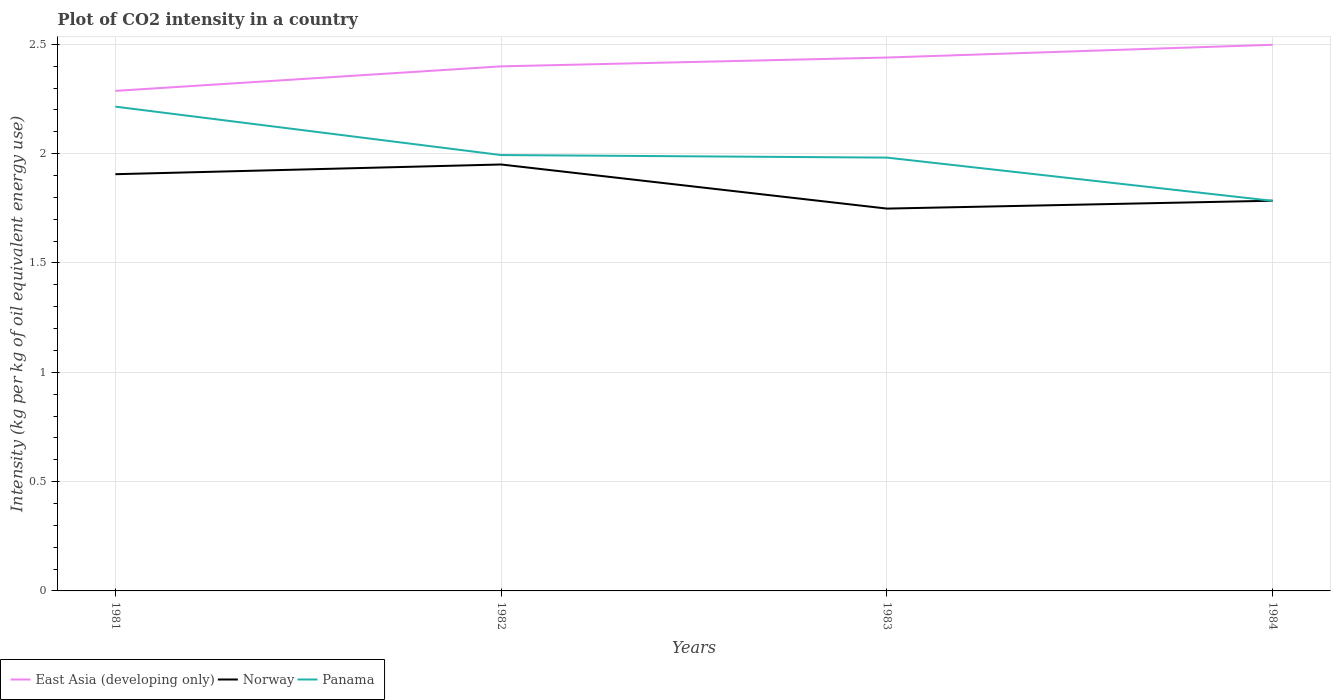Is the number of lines equal to the number of legend labels?
Your response must be concise. Yes. Across all years, what is the maximum CO2 intensity in in Panama?
Provide a succinct answer. 1.78. In which year was the CO2 intensity in in Panama maximum?
Offer a terse response. 1984. What is the total CO2 intensity in in East Asia (developing only) in the graph?
Ensure brevity in your answer.  -0.06. What is the difference between the highest and the second highest CO2 intensity in in Norway?
Make the answer very short. 0.2. Is the CO2 intensity in in Panama strictly greater than the CO2 intensity in in East Asia (developing only) over the years?
Provide a short and direct response. Yes. How many years are there in the graph?
Keep it short and to the point. 4. Does the graph contain any zero values?
Your answer should be compact. No. Does the graph contain grids?
Provide a short and direct response. Yes. How are the legend labels stacked?
Your answer should be very brief. Horizontal. What is the title of the graph?
Offer a terse response. Plot of CO2 intensity in a country. What is the label or title of the X-axis?
Offer a terse response. Years. What is the label or title of the Y-axis?
Your answer should be compact. Intensity (kg per kg of oil equivalent energy use). What is the Intensity (kg per kg of oil equivalent energy use) of East Asia (developing only) in 1981?
Provide a short and direct response. 2.29. What is the Intensity (kg per kg of oil equivalent energy use) in Norway in 1981?
Make the answer very short. 1.91. What is the Intensity (kg per kg of oil equivalent energy use) of Panama in 1981?
Your answer should be very brief. 2.22. What is the Intensity (kg per kg of oil equivalent energy use) of East Asia (developing only) in 1982?
Keep it short and to the point. 2.4. What is the Intensity (kg per kg of oil equivalent energy use) in Norway in 1982?
Offer a very short reply. 1.95. What is the Intensity (kg per kg of oil equivalent energy use) in Panama in 1982?
Offer a very short reply. 1.99. What is the Intensity (kg per kg of oil equivalent energy use) of East Asia (developing only) in 1983?
Give a very brief answer. 2.44. What is the Intensity (kg per kg of oil equivalent energy use) in Norway in 1983?
Provide a short and direct response. 1.75. What is the Intensity (kg per kg of oil equivalent energy use) in Panama in 1983?
Keep it short and to the point. 1.98. What is the Intensity (kg per kg of oil equivalent energy use) in East Asia (developing only) in 1984?
Provide a short and direct response. 2.5. What is the Intensity (kg per kg of oil equivalent energy use) in Norway in 1984?
Your answer should be compact. 1.78. What is the Intensity (kg per kg of oil equivalent energy use) of Panama in 1984?
Make the answer very short. 1.78. Across all years, what is the maximum Intensity (kg per kg of oil equivalent energy use) in East Asia (developing only)?
Ensure brevity in your answer.  2.5. Across all years, what is the maximum Intensity (kg per kg of oil equivalent energy use) in Norway?
Provide a succinct answer. 1.95. Across all years, what is the maximum Intensity (kg per kg of oil equivalent energy use) in Panama?
Keep it short and to the point. 2.22. Across all years, what is the minimum Intensity (kg per kg of oil equivalent energy use) of East Asia (developing only)?
Keep it short and to the point. 2.29. Across all years, what is the minimum Intensity (kg per kg of oil equivalent energy use) in Norway?
Make the answer very short. 1.75. Across all years, what is the minimum Intensity (kg per kg of oil equivalent energy use) of Panama?
Your answer should be compact. 1.78. What is the total Intensity (kg per kg of oil equivalent energy use) in East Asia (developing only) in the graph?
Your response must be concise. 9.62. What is the total Intensity (kg per kg of oil equivalent energy use) in Norway in the graph?
Make the answer very short. 7.39. What is the total Intensity (kg per kg of oil equivalent energy use) in Panama in the graph?
Keep it short and to the point. 7.97. What is the difference between the Intensity (kg per kg of oil equivalent energy use) in East Asia (developing only) in 1981 and that in 1982?
Your answer should be compact. -0.11. What is the difference between the Intensity (kg per kg of oil equivalent energy use) in Norway in 1981 and that in 1982?
Give a very brief answer. -0.04. What is the difference between the Intensity (kg per kg of oil equivalent energy use) of Panama in 1981 and that in 1982?
Make the answer very short. 0.22. What is the difference between the Intensity (kg per kg of oil equivalent energy use) of East Asia (developing only) in 1981 and that in 1983?
Provide a short and direct response. -0.15. What is the difference between the Intensity (kg per kg of oil equivalent energy use) of Norway in 1981 and that in 1983?
Offer a terse response. 0.16. What is the difference between the Intensity (kg per kg of oil equivalent energy use) in Panama in 1981 and that in 1983?
Provide a succinct answer. 0.23. What is the difference between the Intensity (kg per kg of oil equivalent energy use) of East Asia (developing only) in 1981 and that in 1984?
Your answer should be compact. -0.21. What is the difference between the Intensity (kg per kg of oil equivalent energy use) in Norway in 1981 and that in 1984?
Your response must be concise. 0.12. What is the difference between the Intensity (kg per kg of oil equivalent energy use) in Panama in 1981 and that in 1984?
Make the answer very short. 0.43. What is the difference between the Intensity (kg per kg of oil equivalent energy use) in East Asia (developing only) in 1982 and that in 1983?
Provide a succinct answer. -0.04. What is the difference between the Intensity (kg per kg of oil equivalent energy use) in Norway in 1982 and that in 1983?
Make the answer very short. 0.2. What is the difference between the Intensity (kg per kg of oil equivalent energy use) in Panama in 1982 and that in 1983?
Make the answer very short. 0.01. What is the difference between the Intensity (kg per kg of oil equivalent energy use) of East Asia (developing only) in 1982 and that in 1984?
Your answer should be very brief. -0.1. What is the difference between the Intensity (kg per kg of oil equivalent energy use) of Norway in 1982 and that in 1984?
Make the answer very short. 0.17. What is the difference between the Intensity (kg per kg of oil equivalent energy use) of Panama in 1982 and that in 1984?
Offer a very short reply. 0.21. What is the difference between the Intensity (kg per kg of oil equivalent energy use) in East Asia (developing only) in 1983 and that in 1984?
Make the answer very short. -0.06. What is the difference between the Intensity (kg per kg of oil equivalent energy use) in Norway in 1983 and that in 1984?
Offer a terse response. -0.04. What is the difference between the Intensity (kg per kg of oil equivalent energy use) in Panama in 1983 and that in 1984?
Provide a succinct answer. 0.2. What is the difference between the Intensity (kg per kg of oil equivalent energy use) in East Asia (developing only) in 1981 and the Intensity (kg per kg of oil equivalent energy use) in Norway in 1982?
Ensure brevity in your answer.  0.34. What is the difference between the Intensity (kg per kg of oil equivalent energy use) in East Asia (developing only) in 1981 and the Intensity (kg per kg of oil equivalent energy use) in Panama in 1982?
Provide a short and direct response. 0.29. What is the difference between the Intensity (kg per kg of oil equivalent energy use) in Norway in 1981 and the Intensity (kg per kg of oil equivalent energy use) in Panama in 1982?
Give a very brief answer. -0.09. What is the difference between the Intensity (kg per kg of oil equivalent energy use) in East Asia (developing only) in 1981 and the Intensity (kg per kg of oil equivalent energy use) in Norway in 1983?
Your answer should be compact. 0.54. What is the difference between the Intensity (kg per kg of oil equivalent energy use) in East Asia (developing only) in 1981 and the Intensity (kg per kg of oil equivalent energy use) in Panama in 1983?
Offer a terse response. 0.31. What is the difference between the Intensity (kg per kg of oil equivalent energy use) of Norway in 1981 and the Intensity (kg per kg of oil equivalent energy use) of Panama in 1983?
Give a very brief answer. -0.08. What is the difference between the Intensity (kg per kg of oil equivalent energy use) of East Asia (developing only) in 1981 and the Intensity (kg per kg of oil equivalent energy use) of Norway in 1984?
Provide a succinct answer. 0.5. What is the difference between the Intensity (kg per kg of oil equivalent energy use) of East Asia (developing only) in 1981 and the Intensity (kg per kg of oil equivalent energy use) of Panama in 1984?
Offer a very short reply. 0.5. What is the difference between the Intensity (kg per kg of oil equivalent energy use) of Norway in 1981 and the Intensity (kg per kg of oil equivalent energy use) of Panama in 1984?
Offer a terse response. 0.12. What is the difference between the Intensity (kg per kg of oil equivalent energy use) of East Asia (developing only) in 1982 and the Intensity (kg per kg of oil equivalent energy use) of Norway in 1983?
Offer a very short reply. 0.65. What is the difference between the Intensity (kg per kg of oil equivalent energy use) of East Asia (developing only) in 1982 and the Intensity (kg per kg of oil equivalent energy use) of Panama in 1983?
Make the answer very short. 0.42. What is the difference between the Intensity (kg per kg of oil equivalent energy use) of Norway in 1982 and the Intensity (kg per kg of oil equivalent energy use) of Panama in 1983?
Your response must be concise. -0.03. What is the difference between the Intensity (kg per kg of oil equivalent energy use) of East Asia (developing only) in 1982 and the Intensity (kg per kg of oil equivalent energy use) of Norway in 1984?
Provide a succinct answer. 0.61. What is the difference between the Intensity (kg per kg of oil equivalent energy use) in East Asia (developing only) in 1982 and the Intensity (kg per kg of oil equivalent energy use) in Panama in 1984?
Provide a succinct answer. 0.62. What is the difference between the Intensity (kg per kg of oil equivalent energy use) of Norway in 1982 and the Intensity (kg per kg of oil equivalent energy use) of Panama in 1984?
Give a very brief answer. 0.17. What is the difference between the Intensity (kg per kg of oil equivalent energy use) in East Asia (developing only) in 1983 and the Intensity (kg per kg of oil equivalent energy use) in Norway in 1984?
Offer a very short reply. 0.65. What is the difference between the Intensity (kg per kg of oil equivalent energy use) of East Asia (developing only) in 1983 and the Intensity (kg per kg of oil equivalent energy use) of Panama in 1984?
Your response must be concise. 0.66. What is the difference between the Intensity (kg per kg of oil equivalent energy use) of Norway in 1983 and the Intensity (kg per kg of oil equivalent energy use) of Panama in 1984?
Your answer should be very brief. -0.04. What is the average Intensity (kg per kg of oil equivalent energy use) in East Asia (developing only) per year?
Offer a very short reply. 2.41. What is the average Intensity (kg per kg of oil equivalent energy use) of Norway per year?
Provide a short and direct response. 1.85. What is the average Intensity (kg per kg of oil equivalent energy use) in Panama per year?
Your answer should be very brief. 1.99. In the year 1981, what is the difference between the Intensity (kg per kg of oil equivalent energy use) in East Asia (developing only) and Intensity (kg per kg of oil equivalent energy use) in Norway?
Your answer should be very brief. 0.38. In the year 1981, what is the difference between the Intensity (kg per kg of oil equivalent energy use) in East Asia (developing only) and Intensity (kg per kg of oil equivalent energy use) in Panama?
Offer a terse response. 0.07. In the year 1981, what is the difference between the Intensity (kg per kg of oil equivalent energy use) in Norway and Intensity (kg per kg of oil equivalent energy use) in Panama?
Make the answer very short. -0.31. In the year 1982, what is the difference between the Intensity (kg per kg of oil equivalent energy use) of East Asia (developing only) and Intensity (kg per kg of oil equivalent energy use) of Norway?
Give a very brief answer. 0.45. In the year 1982, what is the difference between the Intensity (kg per kg of oil equivalent energy use) in East Asia (developing only) and Intensity (kg per kg of oil equivalent energy use) in Panama?
Your answer should be compact. 0.41. In the year 1982, what is the difference between the Intensity (kg per kg of oil equivalent energy use) of Norway and Intensity (kg per kg of oil equivalent energy use) of Panama?
Your answer should be very brief. -0.04. In the year 1983, what is the difference between the Intensity (kg per kg of oil equivalent energy use) in East Asia (developing only) and Intensity (kg per kg of oil equivalent energy use) in Norway?
Your response must be concise. 0.69. In the year 1983, what is the difference between the Intensity (kg per kg of oil equivalent energy use) in East Asia (developing only) and Intensity (kg per kg of oil equivalent energy use) in Panama?
Offer a very short reply. 0.46. In the year 1983, what is the difference between the Intensity (kg per kg of oil equivalent energy use) in Norway and Intensity (kg per kg of oil equivalent energy use) in Panama?
Provide a succinct answer. -0.23. In the year 1984, what is the difference between the Intensity (kg per kg of oil equivalent energy use) of East Asia (developing only) and Intensity (kg per kg of oil equivalent energy use) of Norway?
Keep it short and to the point. 0.71. In the year 1984, what is the difference between the Intensity (kg per kg of oil equivalent energy use) in East Asia (developing only) and Intensity (kg per kg of oil equivalent energy use) in Panama?
Offer a very short reply. 0.71. In the year 1984, what is the difference between the Intensity (kg per kg of oil equivalent energy use) in Norway and Intensity (kg per kg of oil equivalent energy use) in Panama?
Give a very brief answer. 0. What is the ratio of the Intensity (kg per kg of oil equivalent energy use) in East Asia (developing only) in 1981 to that in 1982?
Provide a short and direct response. 0.95. What is the ratio of the Intensity (kg per kg of oil equivalent energy use) of Norway in 1981 to that in 1982?
Provide a succinct answer. 0.98. What is the ratio of the Intensity (kg per kg of oil equivalent energy use) of Panama in 1981 to that in 1982?
Offer a very short reply. 1.11. What is the ratio of the Intensity (kg per kg of oil equivalent energy use) of East Asia (developing only) in 1981 to that in 1983?
Your answer should be very brief. 0.94. What is the ratio of the Intensity (kg per kg of oil equivalent energy use) in Norway in 1981 to that in 1983?
Your response must be concise. 1.09. What is the ratio of the Intensity (kg per kg of oil equivalent energy use) in Panama in 1981 to that in 1983?
Provide a short and direct response. 1.12. What is the ratio of the Intensity (kg per kg of oil equivalent energy use) of East Asia (developing only) in 1981 to that in 1984?
Your response must be concise. 0.92. What is the ratio of the Intensity (kg per kg of oil equivalent energy use) of Norway in 1981 to that in 1984?
Your answer should be very brief. 1.07. What is the ratio of the Intensity (kg per kg of oil equivalent energy use) of Panama in 1981 to that in 1984?
Keep it short and to the point. 1.24. What is the ratio of the Intensity (kg per kg of oil equivalent energy use) in East Asia (developing only) in 1982 to that in 1983?
Give a very brief answer. 0.98. What is the ratio of the Intensity (kg per kg of oil equivalent energy use) in Norway in 1982 to that in 1983?
Provide a short and direct response. 1.12. What is the ratio of the Intensity (kg per kg of oil equivalent energy use) in Panama in 1982 to that in 1983?
Your answer should be compact. 1.01. What is the ratio of the Intensity (kg per kg of oil equivalent energy use) in East Asia (developing only) in 1982 to that in 1984?
Offer a terse response. 0.96. What is the ratio of the Intensity (kg per kg of oil equivalent energy use) in Norway in 1982 to that in 1984?
Keep it short and to the point. 1.09. What is the ratio of the Intensity (kg per kg of oil equivalent energy use) of Panama in 1982 to that in 1984?
Provide a succinct answer. 1.12. What is the ratio of the Intensity (kg per kg of oil equivalent energy use) in East Asia (developing only) in 1983 to that in 1984?
Keep it short and to the point. 0.98. What is the ratio of the Intensity (kg per kg of oil equivalent energy use) of Norway in 1983 to that in 1984?
Keep it short and to the point. 0.98. What is the ratio of the Intensity (kg per kg of oil equivalent energy use) in Panama in 1983 to that in 1984?
Your answer should be very brief. 1.11. What is the difference between the highest and the second highest Intensity (kg per kg of oil equivalent energy use) in East Asia (developing only)?
Provide a succinct answer. 0.06. What is the difference between the highest and the second highest Intensity (kg per kg of oil equivalent energy use) in Norway?
Offer a terse response. 0.04. What is the difference between the highest and the second highest Intensity (kg per kg of oil equivalent energy use) of Panama?
Your answer should be very brief. 0.22. What is the difference between the highest and the lowest Intensity (kg per kg of oil equivalent energy use) of East Asia (developing only)?
Make the answer very short. 0.21. What is the difference between the highest and the lowest Intensity (kg per kg of oil equivalent energy use) of Norway?
Provide a succinct answer. 0.2. What is the difference between the highest and the lowest Intensity (kg per kg of oil equivalent energy use) in Panama?
Ensure brevity in your answer.  0.43. 